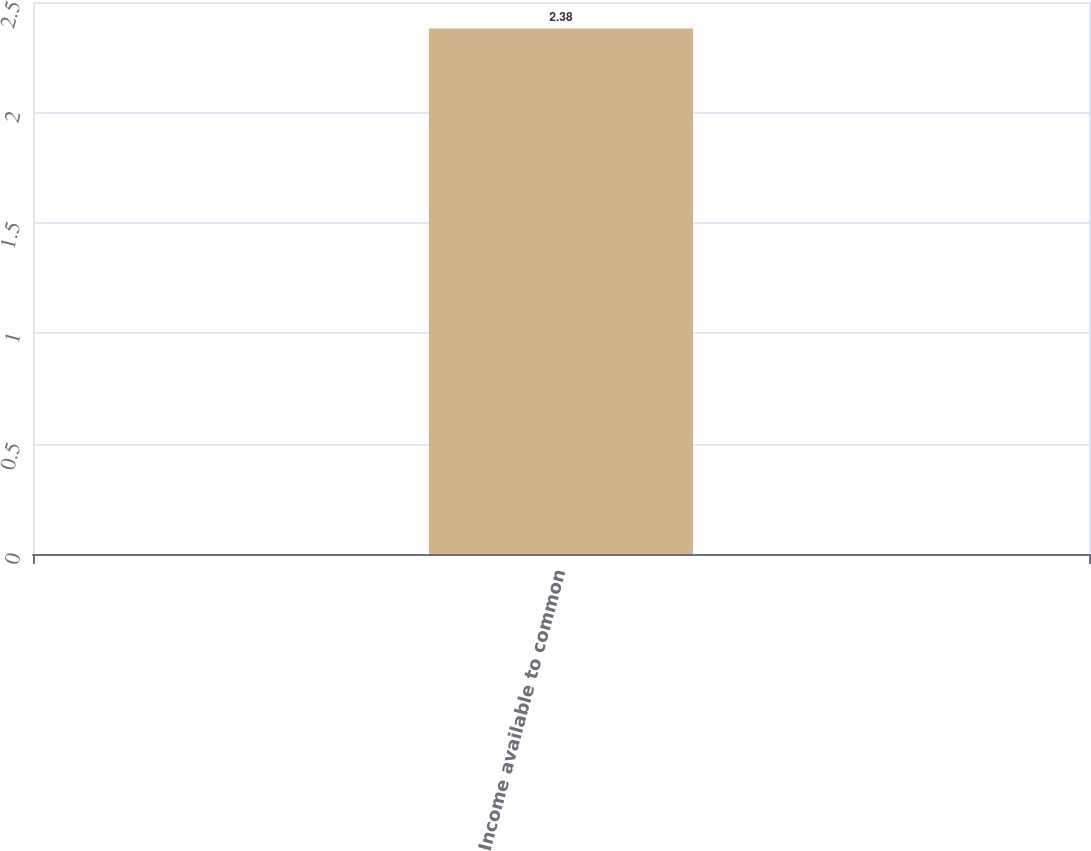Convert chart to OTSL. <chart><loc_0><loc_0><loc_500><loc_500><bar_chart><fcel>Income available to common<nl><fcel>2.38<nl></chart> 